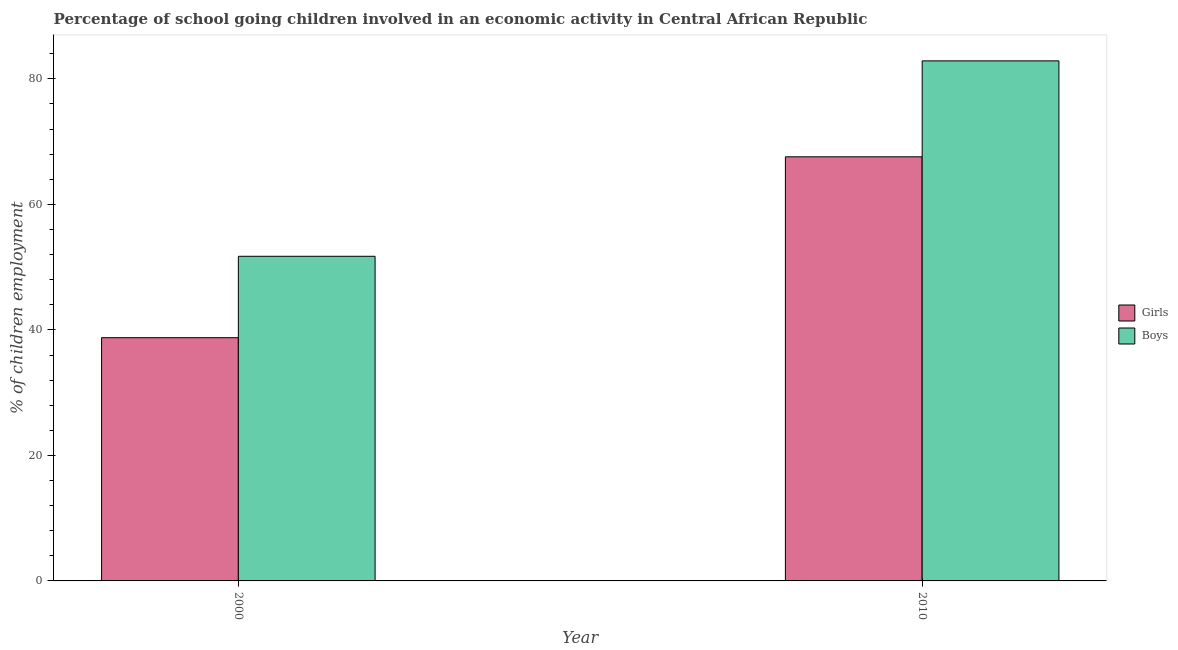How many groups of bars are there?
Offer a terse response. 2. Are the number of bars per tick equal to the number of legend labels?
Offer a very short reply. Yes. Are the number of bars on each tick of the X-axis equal?
Make the answer very short. Yes. How many bars are there on the 2nd tick from the left?
Keep it short and to the point. 2. How many bars are there on the 1st tick from the right?
Offer a terse response. 2. What is the label of the 2nd group of bars from the left?
Your answer should be very brief. 2010. In how many cases, is the number of bars for a given year not equal to the number of legend labels?
Give a very brief answer. 0. What is the percentage of school going girls in 2010?
Your response must be concise. 67.58. Across all years, what is the maximum percentage of school going girls?
Ensure brevity in your answer.  67.58. Across all years, what is the minimum percentage of school going girls?
Give a very brief answer. 38.76. In which year was the percentage of school going boys maximum?
Offer a very short reply. 2010. What is the total percentage of school going boys in the graph?
Give a very brief answer. 134.6. What is the difference between the percentage of school going girls in 2000 and that in 2010?
Your answer should be compact. -28.82. What is the difference between the percentage of school going girls in 2010 and the percentage of school going boys in 2000?
Make the answer very short. 28.82. What is the average percentage of school going girls per year?
Ensure brevity in your answer.  53.17. In the year 2010, what is the difference between the percentage of school going girls and percentage of school going boys?
Your answer should be very brief. 0. What is the ratio of the percentage of school going boys in 2000 to that in 2010?
Your answer should be very brief. 0.62. What does the 2nd bar from the left in 2010 represents?
Offer a terse response. Boys. What does the 1st bar from the right in 2000 represents?
Your answer should be compact. Boys. Are all the bars in the graph horizontal?
Your response must be concise. No. How many years are there in the graph?
Your answer should be very brief. 2. What is the difference between two consecutive major ticks on the Y-axis?
Offer a very short reply. 20. Are the values on the major ticks of Y-axis written in scientific E-notation?
Make the answer very short. No. Does the graph contain any zero values?
Ensure brevity in your answer.  No. Does the graph contain grids?
Your response must be concise. No. How many legend labels are there?
Give a very brief answer. 2. What is the title of the graph?
Make the answer very short. Percentage of school going children involved in an economic activity in Central African Republic. Does "Drinking water services" appear as one of the legend labels in the graph?
Give a very brief answer. No. What is the label or title of the X-axis?
Make the answer very short. Year. What is the label or title of the Y-axis?
Provide a succinct answer. % of children employment. What is the % of children employment in Girls in 2000?
Keep it short and to the point. 38.76. What is the % of children employment of Boys in 2000?
Make the answer very short. 51.73. What is the % of children employment of Girls in 2010?
Provide a succinct answer. 67.58. What is the % of children employment in Boys in 2010?
Provide a short and direct response. 82.87. Across all years, what is the maximum % of children employment in Girls?
Provide a succinct answer. 67.58. Across all years, what is the maximum % of children employment of Boys?
Your answer should be compact. 82.87. Across all years, what is the minimum % of children employment in Girls?
Offer a very short reply. 38.76. Across all years, what is the minimum % of children employment of Boys?
Provide a succinct answer. 51.73. What is the total % of children employment of Girls in the graph?
Your response must be concise. 106.34. What is the total % of children employment of Boys in the graph?
Offer a terse response. 134.6. What is the difference between the % of children employment of Girls in 2000 and that in 2010?
Give a very brief answer. -28.82. What is the difference between the % of children employment in Boys in 2000 and that in 2010?
Keep it short and to the point. -31.14. What is the difference between the % of children employment in Girls in 2000 and the % of children employment in Boys in 2010?
Your answer should be very brief. -44.11. What is the average % of children employment in Girls per year?
Ensure brevity in your answer.  53.17. What is the average % of children employment in Boys per year?
Offer a very short reply. 67.3. In the year 2000, what is the difference between the % of children employment in Girls and % of children employment in Boys?
Provide a succinct answer. -12.97. In the year 2010, what is the difference between the % of children employment in Girls and % of children employment in Boys?
Your answer should be very brief. -15.29. What is the ratio of the % of children employment of Girls in 2000 to that in 2010?
Make the answer very short. 0.57. What is the ratio of the % of children employment in Boys in 2000 to that in 2010?
Keep it short and to the point. 0.62. What is the difference between the highest and the second highest % of children employment of Girls?
Provide a short and direct response. 28.82. What is the difference between the highest and the second highest % of children employment of Boys?
Your answer should be compact. 31.14. What is the difference between the highest and the lowest % of children employment of Girls?
Make the answer very short. 28.82. What is the difference between the highest and the lowest % of children employment in Boys?
Your answer should be very brief. 31.14. 